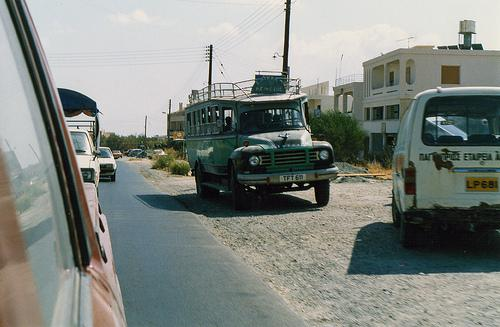Question: where are the cars?
Choices:
A. Street.
B. Parking lot.
C. Garage.
D. Bridge.
Answer with the letter. Answer: A Question: what is the weather like?
Choices:
A. Cloudy.
B. Clear.
C. Rainy.
D. Snowy.
Answer with the letter. Answer: B 